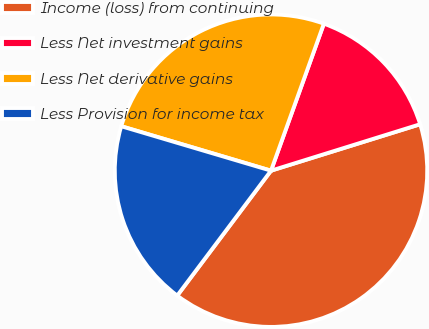<chart> <loc_0><loc_0><loc_500><loc_500><pie_chart><fcel>Income (loss) from continuing<fcel>Less Net investment gains<fcel>Less Net derivative gains<fcel>Less Provision for income tax<nl><fcel>40.05%<fcel>14.7%<fcel>25.9%<fcel>19.34%<nl></chart> 